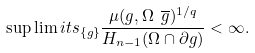<formula> <loc_0><loc_0><loc_500><loc_500>\sup \lim i t s _ { \{ g \} } \frac { \mu ( g , \Omega \ \overline { g } ) ^ { 1 / q } } { H _ { n - 1 } ( \Omega \cap \partial g ) } < \infty .</formula> 